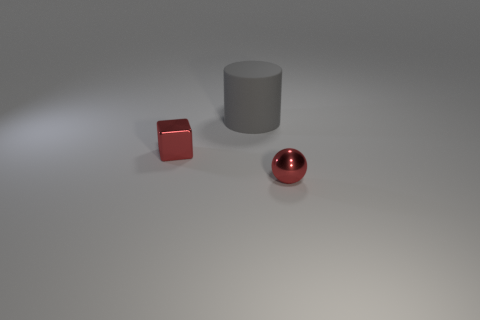How many other things are the same size as the sphere?
Your response must be concise. 1. There is a red shiny object that is on the left side of the red shiny sphere; what size is it?
Your response must be concise. Small. The tiny object that is the same material as the tiny red block is what shape?
Offer a terse response. Sphere. Is there anything else of the same color as the small metallic cube?
Provide a short and direct response. Yes. What color is the tiny thing left of the small metallic object in front of the small metallic block?
Provide a succinct answer. Red. How many small objects are either cubes or yellow matte cubes?
Keep it short and to the point. 1. Is there any other thing that has the same material as the large thing?
Offer a terse response. No. What color is the big rubber object?
Provide a short and direct response. Gray. Do the matte cylinder and the tiny ball have the same color?
Provide a succinct answer. No. What number of blocks are right of the small object to the right of the small block?
Keep it short and to the point. 0. 